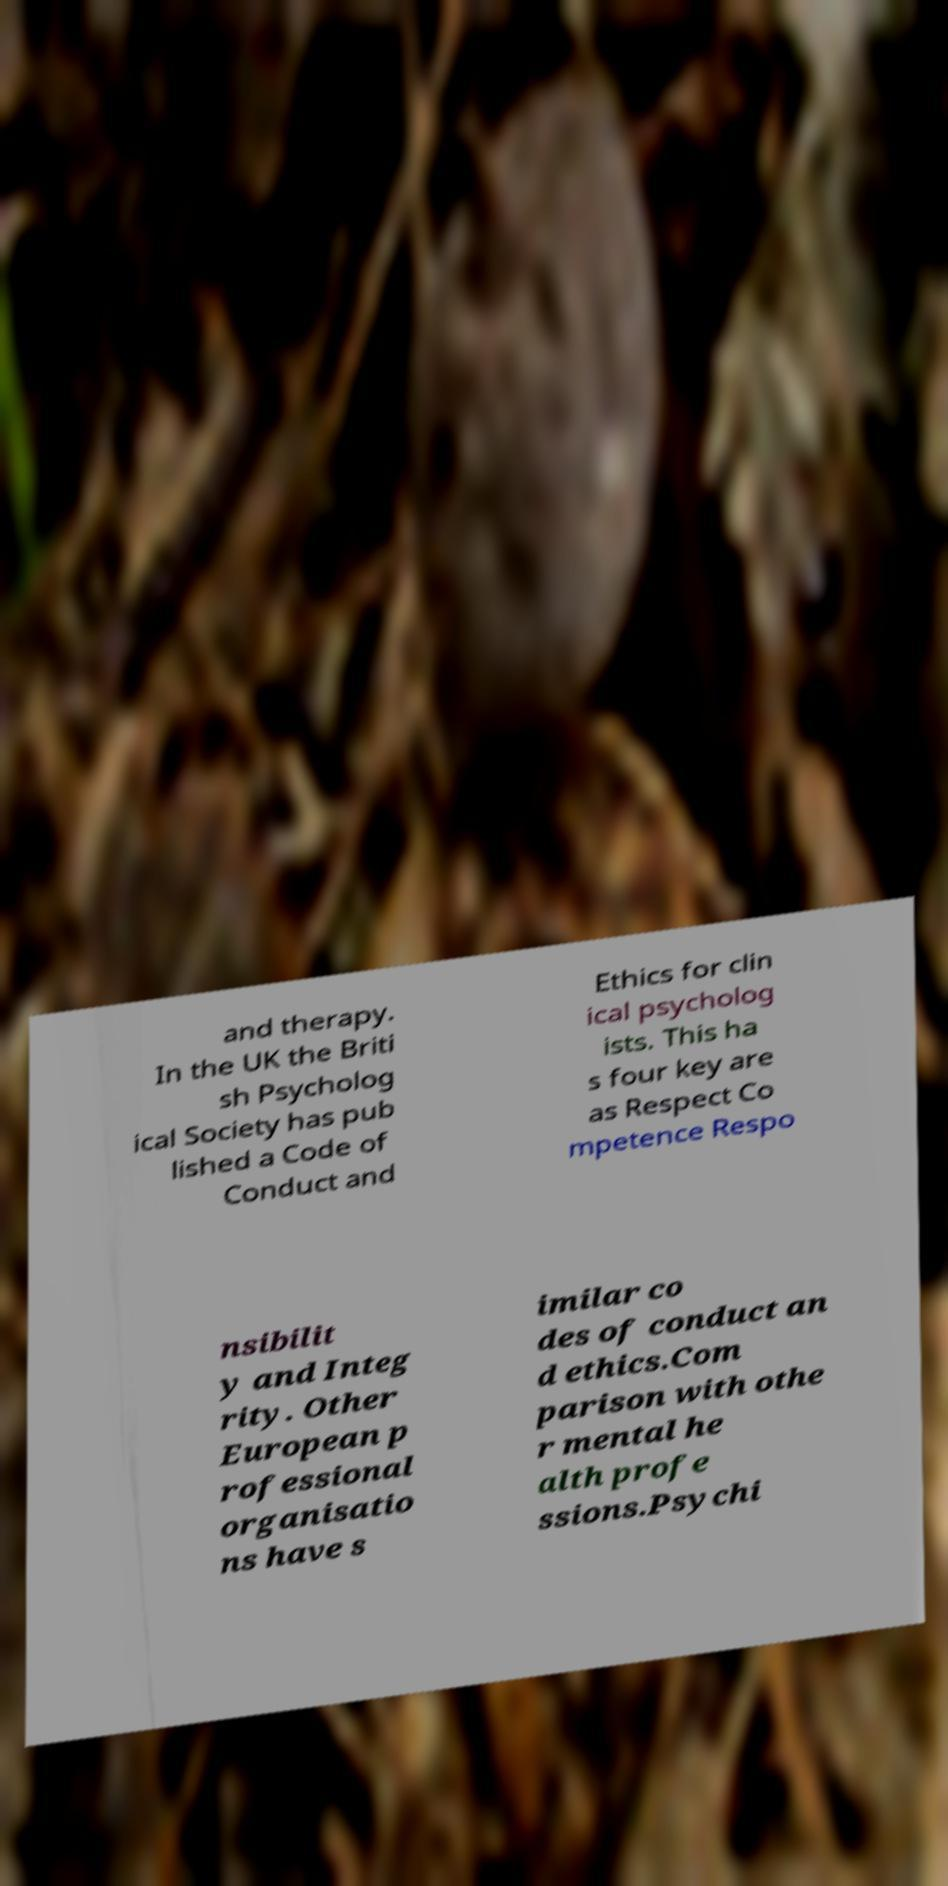What messages or text are displayed in this image? I need them in a readable, typed format. and therapy. In the UK the Briti sh Psycholog ical Society has pub lished a Code of Conduct and Ethics for clin ical psycholog ists. This ha s four key are as Respect Co mpetence Respo nsibilit y and Integ rity. Other European p rofessional organisatio ns have s imilar co des of conduct an d ethics.Com parison with othe r mental he alth profe ssions.Psychi 